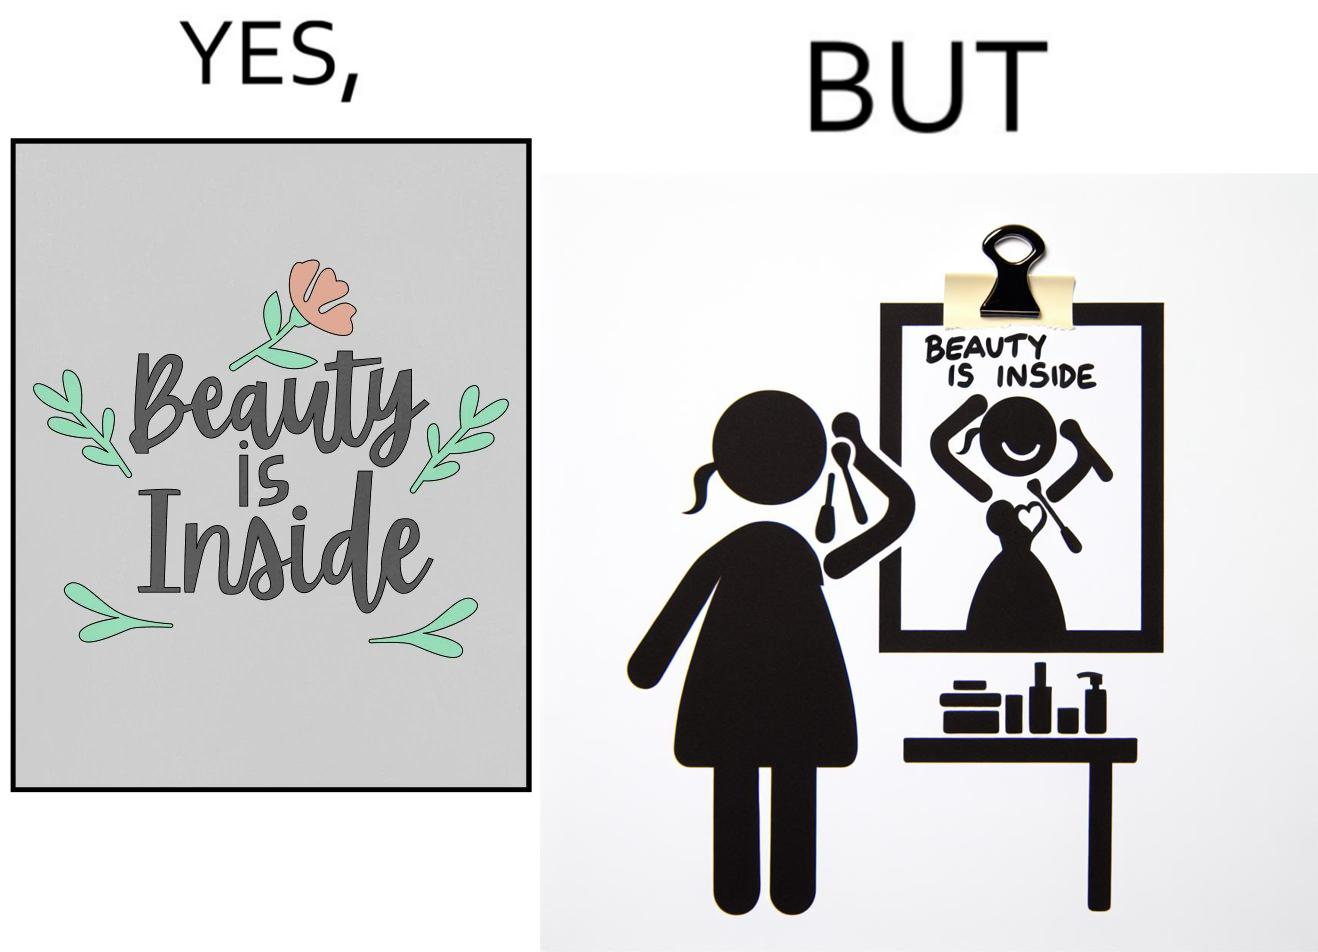Describe what you see in this image. The image is satirical because while the text on the paper says that beauty lies inside, the woman ignores the note and continues to apply makeup to improve her outer beauty. 